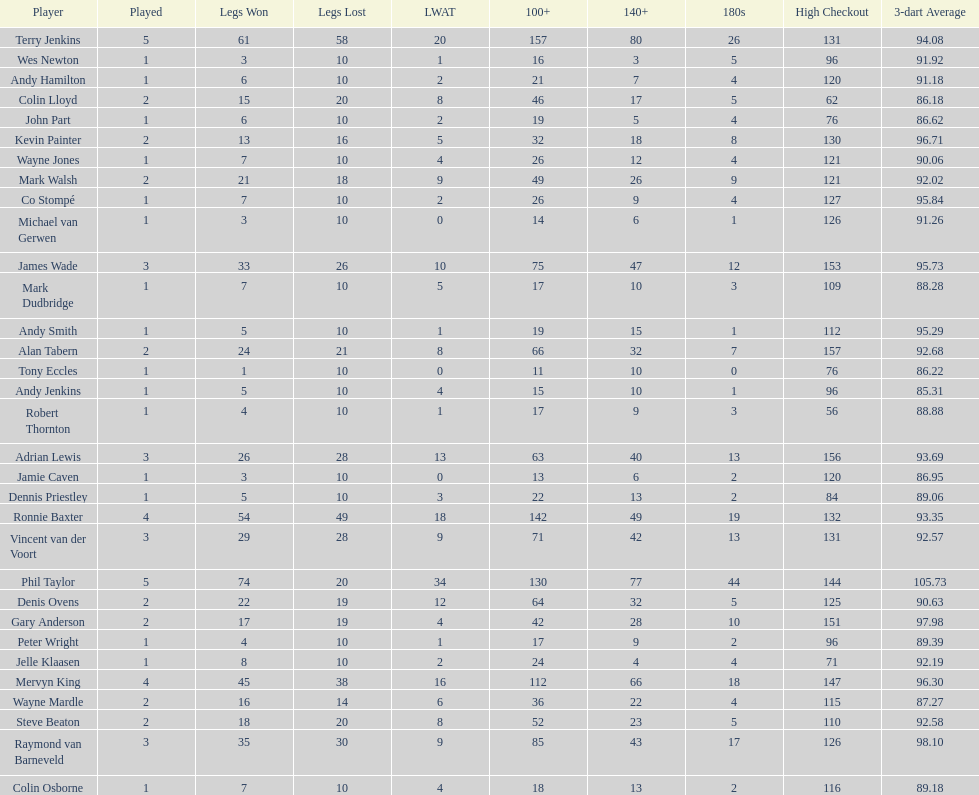What is the name of the next player after mark walsh? Wes Newton. 